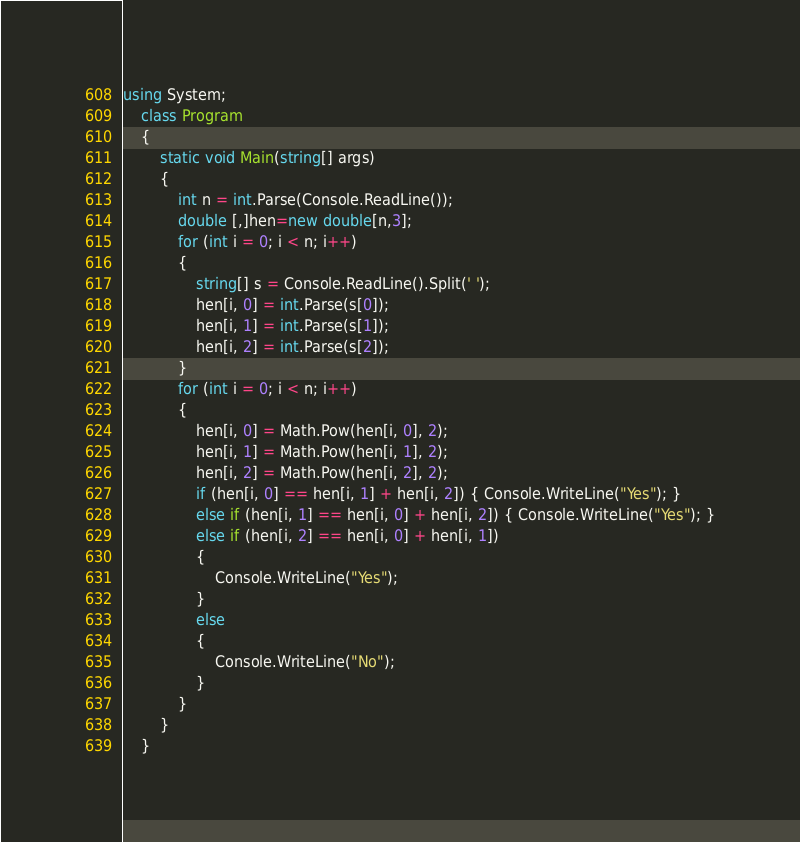Convert code to text. <code><loc_0><loc_0><loc_500><loc_500><_C#_>using System;
    class Program
    {
        static void Main(string[] args)
        {
            int n = int.Parse(Console.ReadLine());
            double [,]hen=new double[n,3];
            for (int i = 0; i < n; i++)
            {
                string[] s = Console.ReadLine().Split(' ');
                hen[i, 0] = int.Parse(s[0]);
                hen[i, 1] = int.Parse(s[1]);
                hen[i, 2] = int.Parse(s[2]);
            }
            for (int i = 0; i < n; i++)
            {
                hen[i, 0] = Math.Pow(hen[i, 0], 2);
                hen[i, 1] = Math.Pow(hen[i, 1], 2);
                hen[i, 2] = Math.Pow(hen[i, 2], 2);
                if (hen[i, 0] == hen[i, 1] + hen[i, 2]) { Console.WriteLine("Yes"); }
                else if (hen[i, 1] == hen[i, 0] + hen[i, 2]) { Console.WriteLine("Yes"); }
                else if (hen[i, 2] == hen[i, 0] + hen[i, 1]) 
                {
                    Console.WriteLine("Yes");
                }
                else
                {
                    Console.WriteLine("No");
                }
            }
        }
    }</code> 